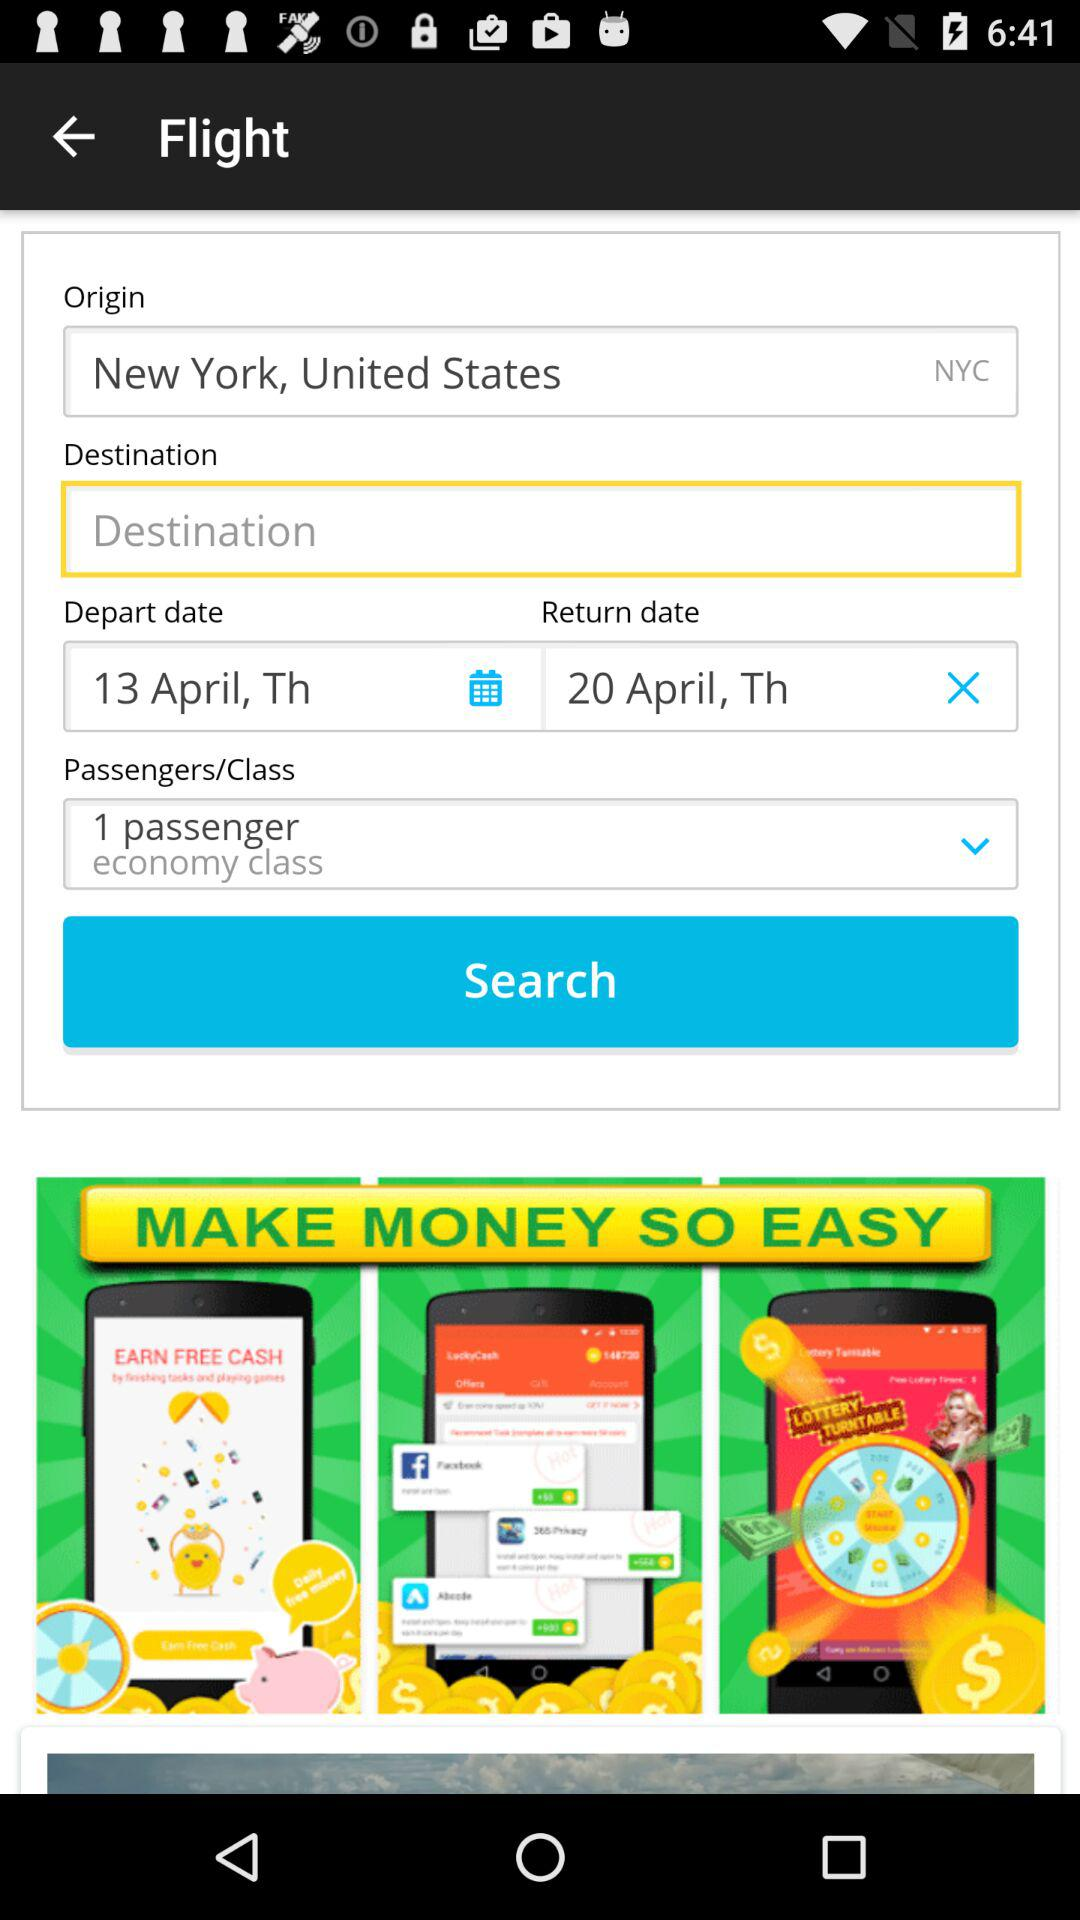How many passengers are selected for this flight?
Answer the question using a single word or phrase. 1 